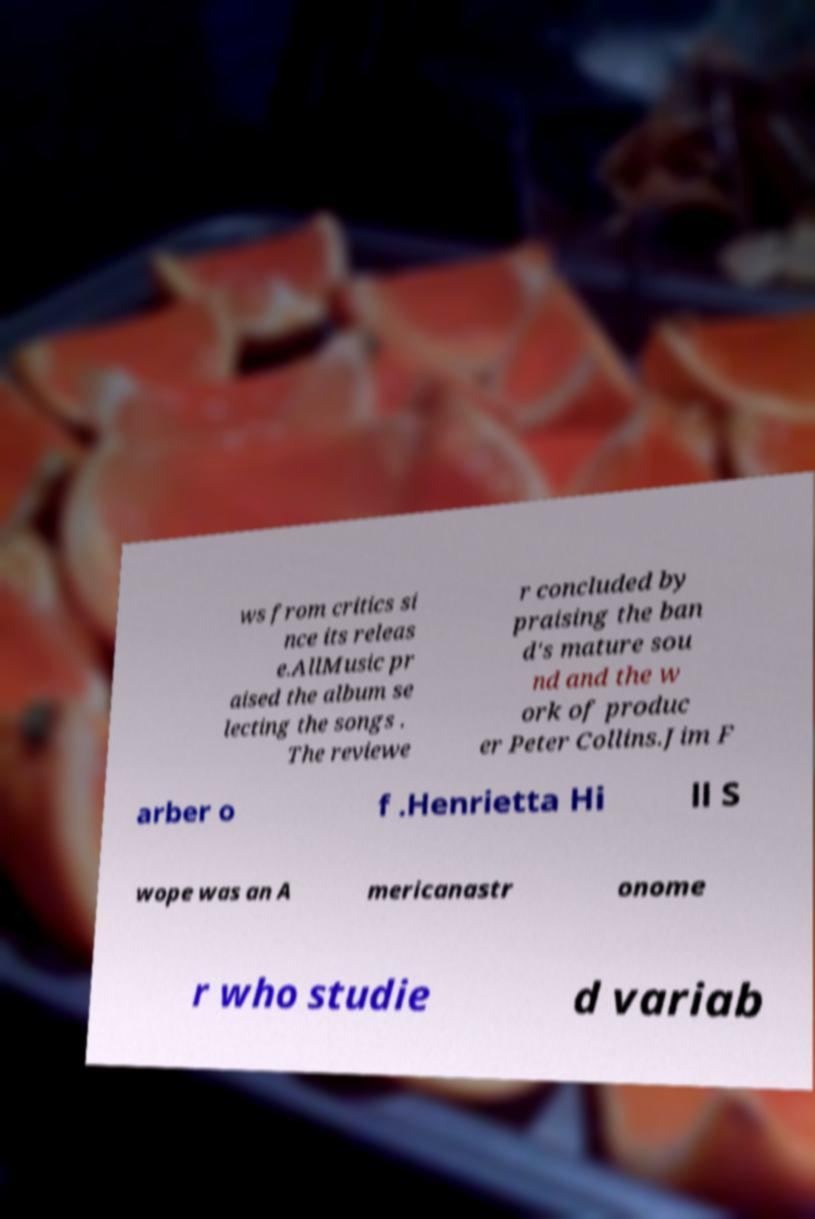Could you assist in decoding the text presented in this image and type it out clearly? ws from critics si nce its releas e.AllMusic pr aised the album se lecting the songs . The reviewe r concluded by praising the ban d's mature sou nd and the w ork of produc er Peter Collins.Jim F arber o f .Henrietta Hi ll S wope was an A mericanastr onome r who studie d variab 